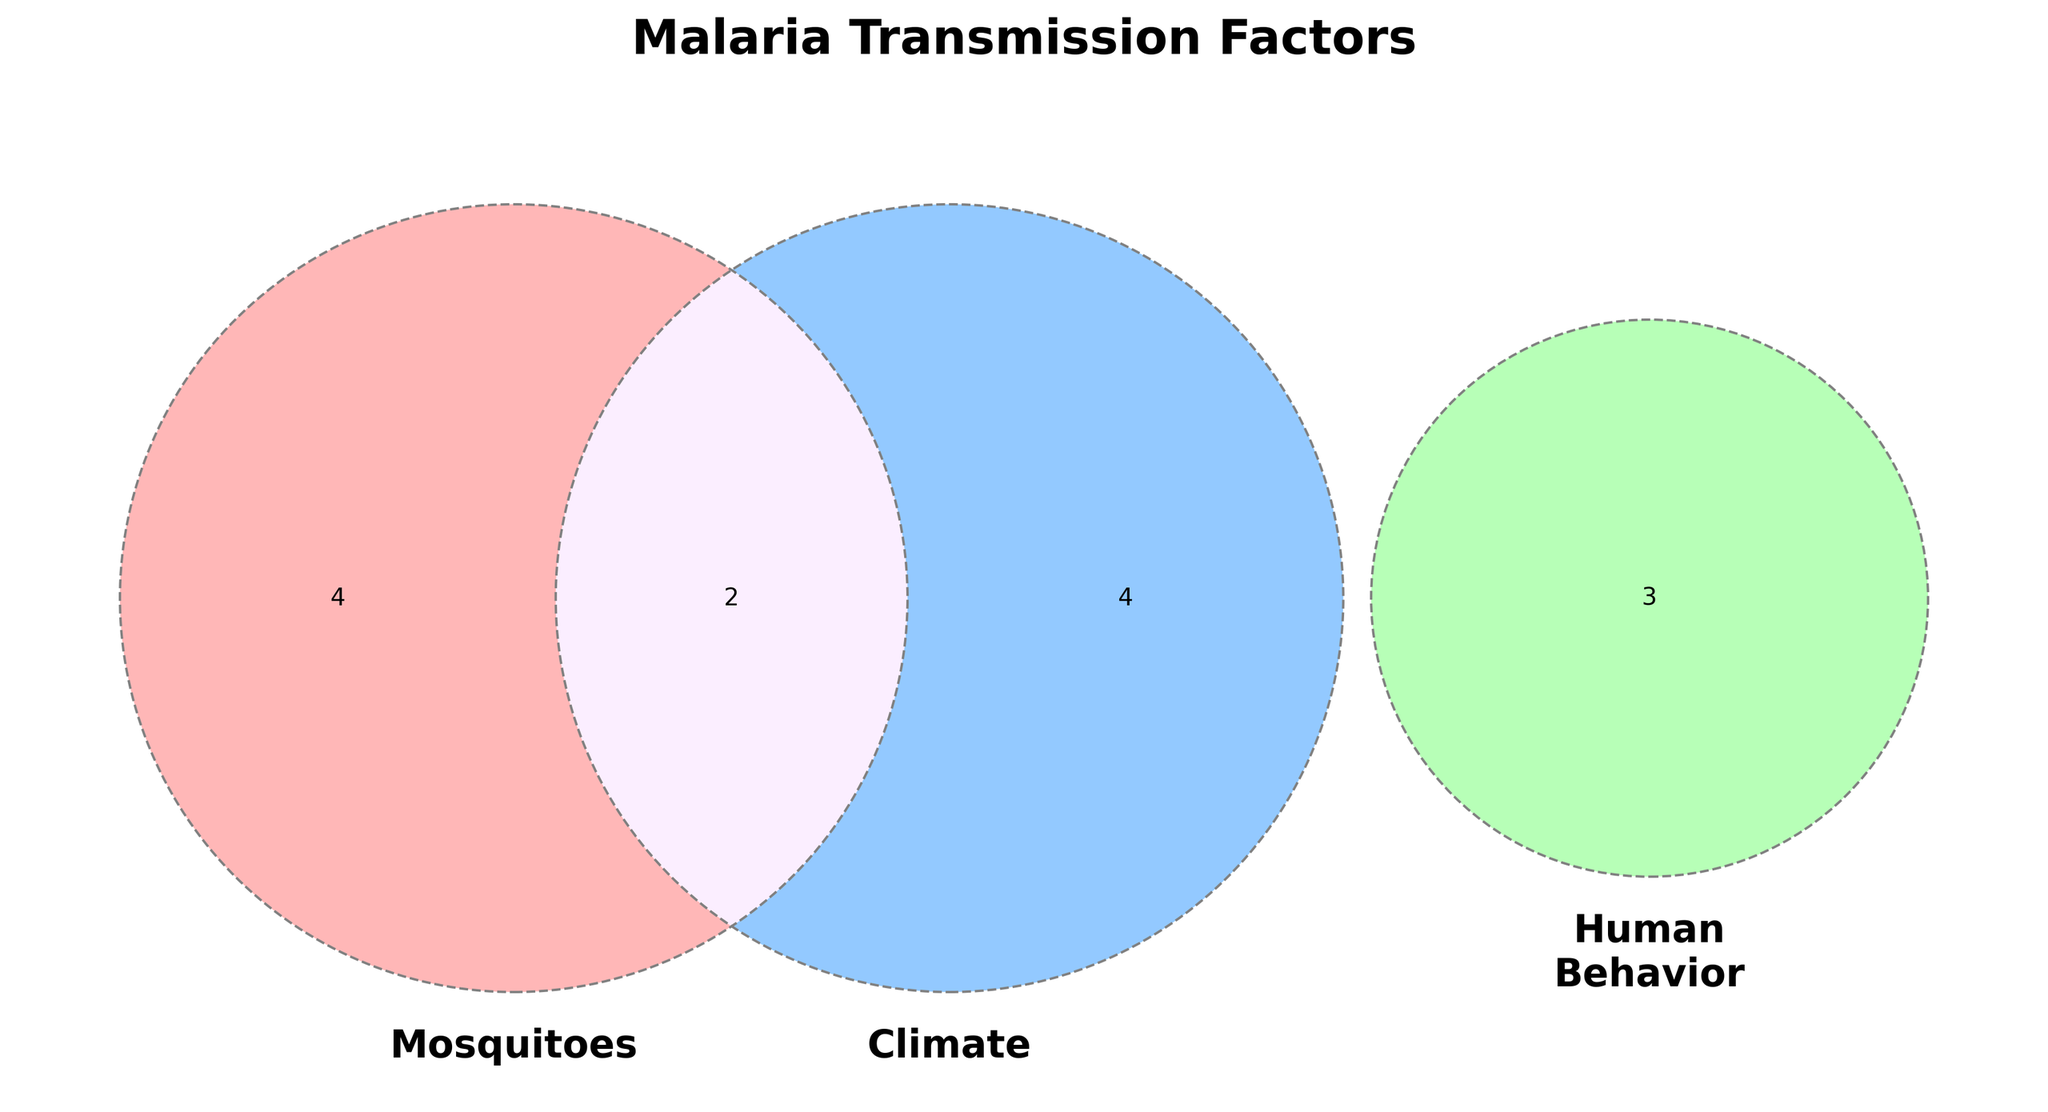What factors are listed under the 'Climate' category? The 'Climate' category in the figure includes Rainfall patterns, Temperature, and Humidity.
Answer: Rainfall patterns, Temperature, Humidity Which category includes insecticide resistance as a factor? In the Venn diagram, the 'Mosquitoes' category lists insecticide resistance as a factor.
Answer: Mosquitoes What is the title of the Venn diagram? The title of the Venn diagram is displayed at the top and reads 'Malaria Transmission Factors'.
Answer: Malaria Transmission Factors Which factors are common to both 'Mosquitoes' and 'Climate'? The Venn diagram shows that Seasonal variations are the factors common to both 'Mosquitoes' and 'Climate'.
Answer: Seasonal variations Compare the factors listed under 'Human Behavior' and 'Mosquitoes'. Which category has more factors? Counting the factors, 'Human Behavior' includes Outdoor activities, Use of bed nets, and Housing conditions (3 factors), while 'Mosquitoes' has Anopheles species, Breeding sites, and Insecticide resistance (3 factors). Both have the same number of factors.
Answer: Same number of factors Identify the factors that are influenced by all three categories. The Venn diagram indicates that Water management is the factor influenced by 'Mosquitoes', 'Climate', and 'Human Behavior'.
Answer: Water management Which categories intersect the least with others, based on visible sections with no overlaps? 'Climate' and 'Human Behavior' intersect the least with others, each having individual sections without overlaps with other categories.
Answer: Climate, Human Behavior What is the difference in the number of common factors between 'Mosquitoes' and 'Climate' versus 'Climate' and 'Human Behavior'? 'Mosquitoes' and 'Climate' share Seasonal variations (1 factor), while 'Climate' and 'Human Behavior' share Agricultural practices (1 factor). The difference is 0.
Answer: 0 Which factor is common to 'Mosquitoes' and 'Human Behavior' but not to 'Climate'? Nighttime exposure is the factor common to 'Mosquitoes' and 'Human Behavior' but not to 'Climate'.
Answer: Nighttime exposure 